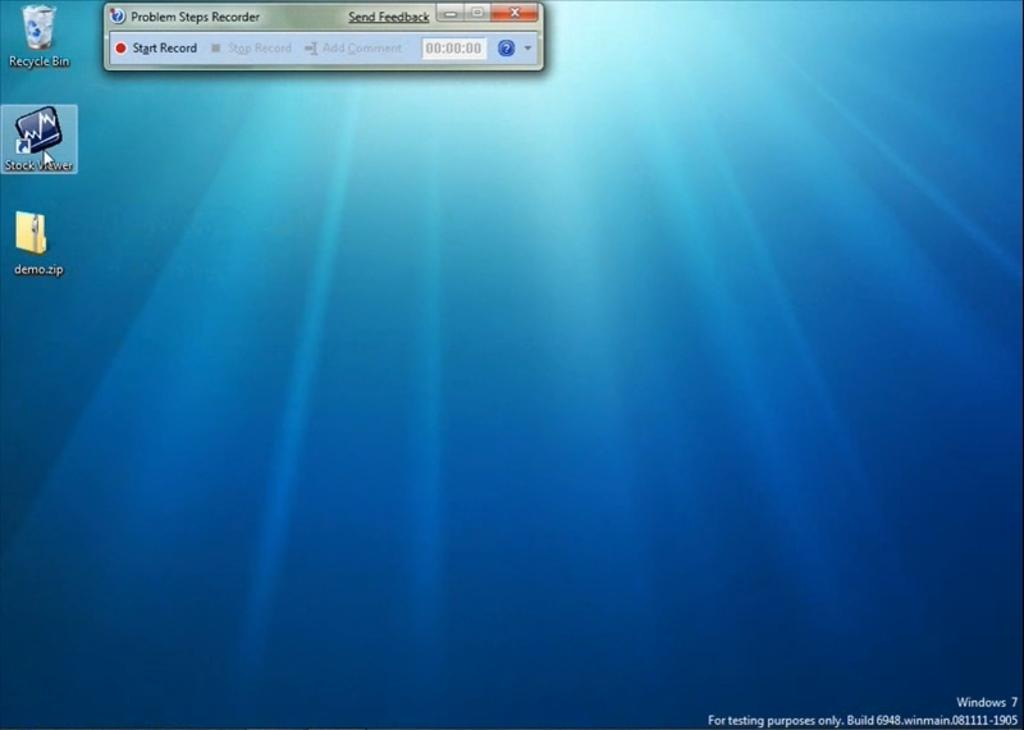Provide a one-sentence caption for the provided image. A screenshot of a computer desktop with an app called stock viewer selected. 